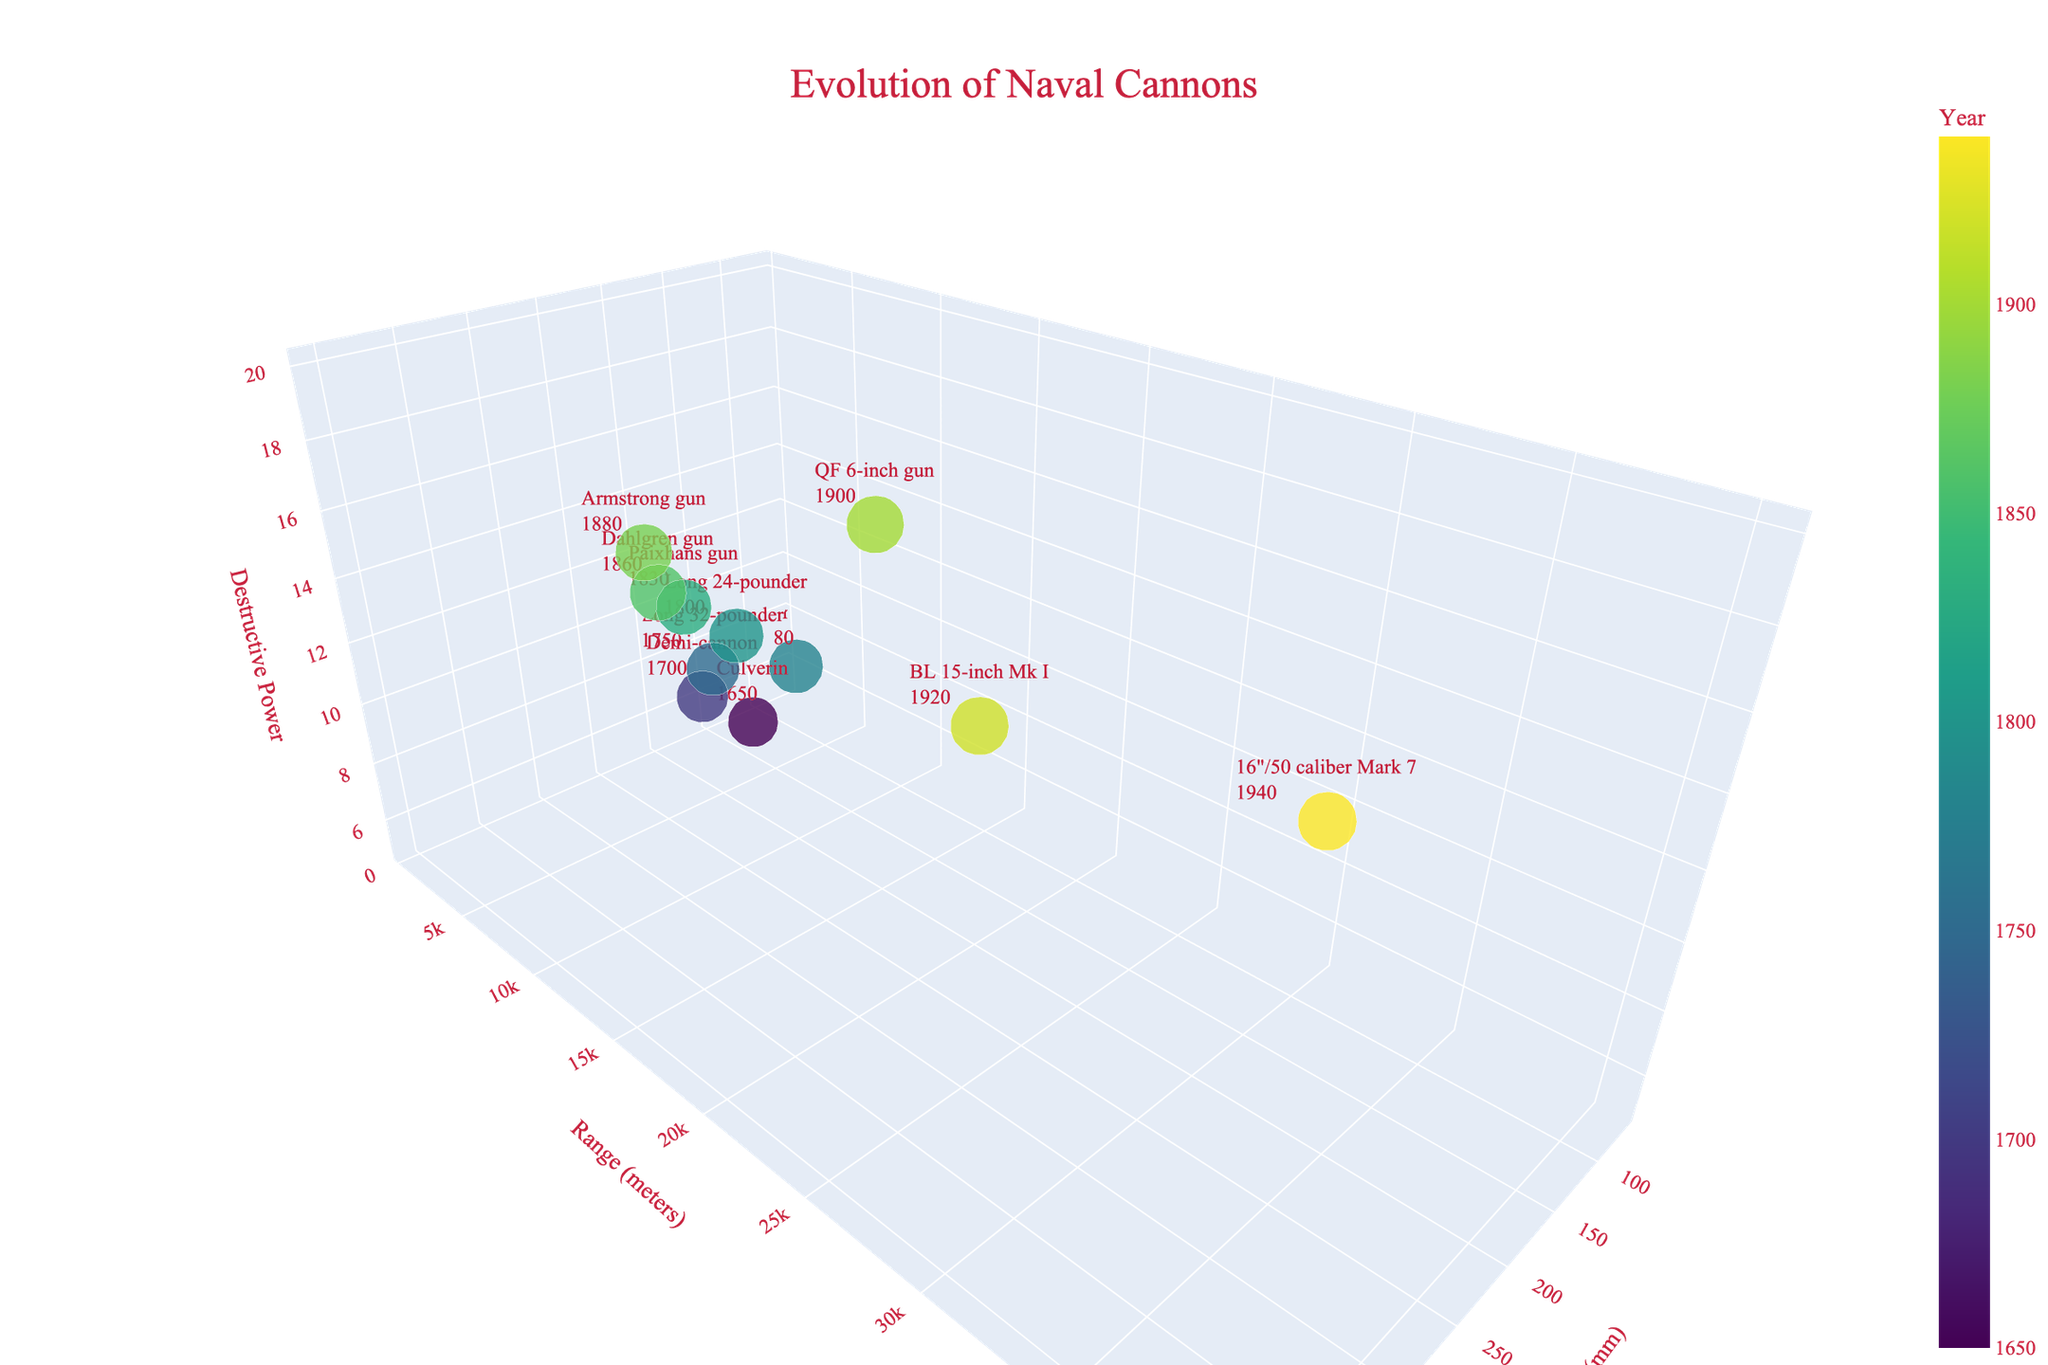What's the title of the plot? The title is usually found at the top of the plot, displayed in a larger font size and often centered. In this case, the provided data shows the title: "Evolution of Naval Cannons".
Answer: Evolution of Naval Cannons How many different types of cannons are shown in the plot? Each point in the 3D scatter plot represents a different type of cannon, identifiable by hovering over the points which displays the text labels. From the data provided, there are 11 different cannon types listed.
Answer: 11 Which cannon type has the highest destructive power? To find the cannon with the highest destructive power, we look for the data point with the highest value on the z-axis. From the provided data, the "16\"/50 caliber Mark 7" cannon, introduced in 1940, has the highest destructive power of 20.
Answer: 16"/50 caliber Mark 7 During what year was the cannon with the longest range introduced? By examining the y-axis for the highest range value, we see the "16\"/50 caliber Mark 7" cannon from 1940 has the longest range, which is 40,000 meters.
Answer: 1940 Which cannon has the smallest caliber but a destructive power of 6? By plotting both the caliber and destructive power, the smallest caliber with a destructive power of 6 corresponds to the Carronade from 1780, with a caliber of 68 mm.
Answer: Carronade What is the difference in the range between the Culverin and the QF 6-inch gun? The range of the Culverin is 1,800 meters, and the range of the QF 6-inch gun is 12,000 meters. The difference is calculated as 12,000 - 1,800 = 10,200 meters.
Answer: 10,200 meters How does the Paixhans gun compare to the Armstrong gun in terms of caliber and destructive power? The Paixhans gun introduced in 1830 has a caliber of 203 mm and a destructive power of 11, while the Armstrong gun from 1880 has a caliber of 254 mm and a destructive power of 14. Thus, the Armstrong gun has a larger caliber and higher destructive power.
Answer: Armstrong gun has larger caliber and higher power What is the average range of all the cannons introduced before 1800? We sum the ranges of the cannons introduced before 1800, which are Culverin (1,800), Demi-cannon (2,200), Long 32-pounder (2,500), Carronade (900), and Long 24-pounder (2,800), and then divide by the number of entries, 5. The average range calculation is (1,800 + 2,200 + 2,500 + 900 + 2,800) / 5 = 10,200 / 5 = 2,040 meters.
Answer: 2,040 meters Which cannon type became more destructive but had lesser range than its predecessor? Comparing consecutive cannon types, the Carronade (1780) with a destructive power of 6 and range of 900 meters is more destructive but has a lesser range than the Long 32-pounder (1750) which has a destructive power of 8 and range of 2,500 meters.
Answer: Carronade 